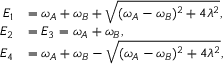Convert formula to latex. <formula><loc_0><loc_0><loc_500><loc_500>\begin{array} { r l } { E _ { 1 } } & { = \omega _ { A } + \omega _ { B } + \sqrt { ( \omega _ { A } - \omega _ { B } ) ^ { 2 } + 4 \lambda ^ { 2 } } , } \\ { E _ { 2 } } & { = E _ { 3 } = \omega _ { A } + \omega _ { B } , } \\ { E _ { 4 } } & { = \omega _ { A } + \omega _ { B } - \sqrt { ( \omega _ { A } - \omega _ { B } ) ^ { 2 } + 4 \lambda ^ { 2 } } , } \end{array}</formula> 